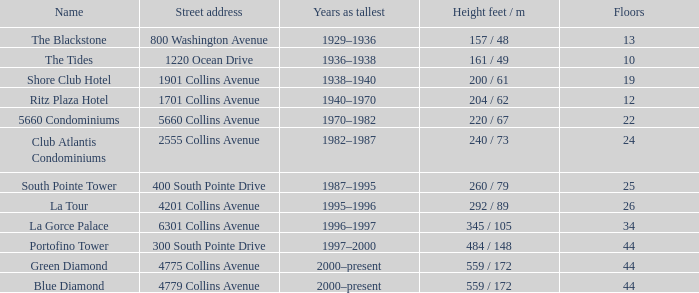How many storeys are there in the blue diamond? 44.0. 